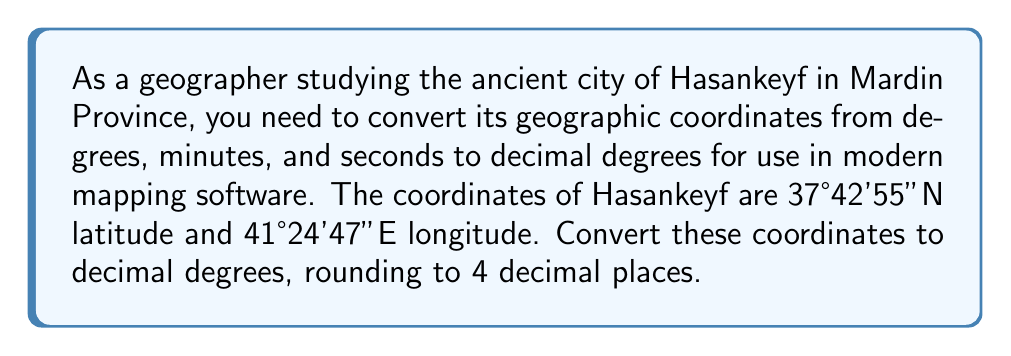Provide a solution to this math problem. To convert geographic coordinates from degrees, minutes, and seconds (DMS) to decimal degrees (DD), we use the following formula:

$$ DD = d + \frac{m}{60} + \frac{s}{3600} $$

Where:
$d$ = degrees
$m$ = minutes
$s$ = seconds

For latitude (37°42'55"N):
$d = 37$, $m = 42$, $s = 55$

$$ DD_{lat} = 37 + \frac{42}{60} + \frac{55}{3600} $$
$$ = 37 + 0.7 + 0.0152777... $$
$$ = 37.7152777... $$

Rounding to 4 decimal places: 37.7153°N

For longitude (41°24'47"E):
$d = 41$, $m = 24$, $s = 47$

$$ DD_{lon} = 41 + \frac{24}{60} + \frac{47}{3600} $$
$$ = 41 + 0.4 + 0.0130555... $$
$$ = 41.4130555... $$

Rounding to 4 decimal places: 41.4131°E

Note: The cardinal directions (N and E) remain the same in decimal degree format. If it were S or W, the result would be negative.
Answer: The coordinates of Hasankeyf in decimal degrees are 37.7153°N, 41.4131°E. 